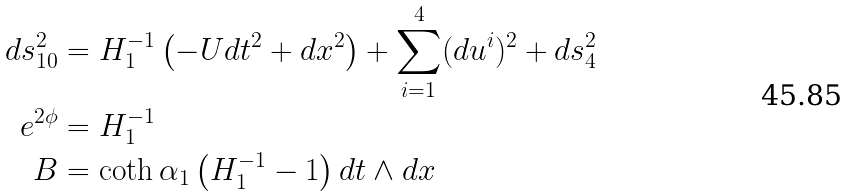Convert formula to latex. <formula><loc_0><loc_0><loc_500><loc_500>d s ^ { 2 } _ { 1 0 } & = H _ { 1 } ^ { - 1 } \left ( - U d t ^ { 2 } + d x ^ { 2 } \right ) + \sum _ { i = 1 } ^ { 4 } ( d u ^ { i } ) ^ { 2 } + d s _ { 4 } ^ { 2 } \\ e ^ { 2 \phi } & = H _ { 1 } ^ { - 1 } \\ B & = \coth \alpha _ { 1 } \left ( H _ { 1 } ^ { - 1 } - 1 \right ) d t \wedge d x</formula> 